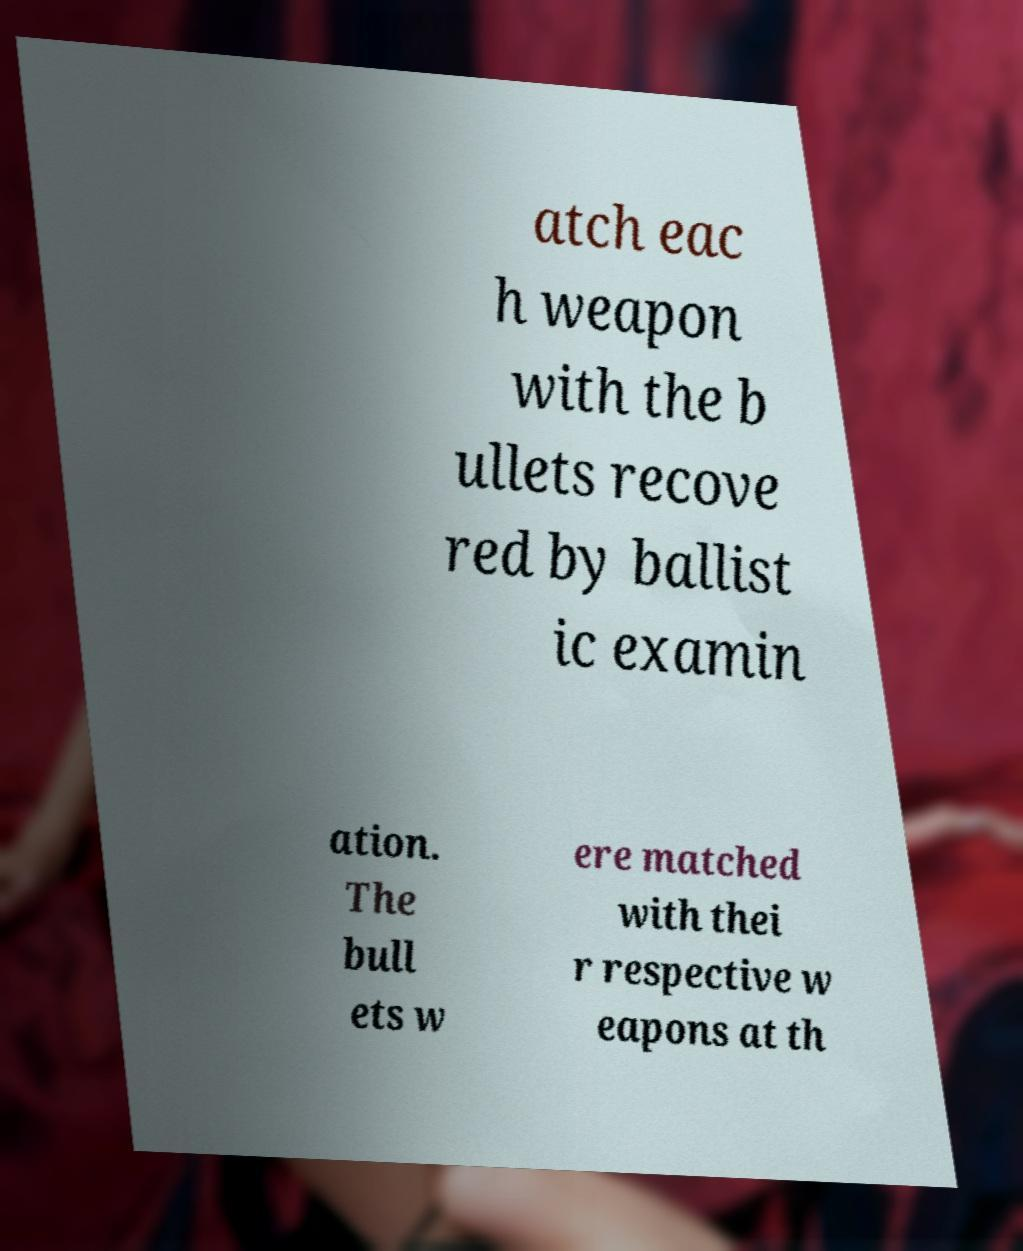There's text embedded in this image that I need extracted. Can you transcribe it verbatim? atch eac h weapon with the b ullets recove red by ballist ic examin ation. The bull ets w ere matched with thei r respective w eapons at th 